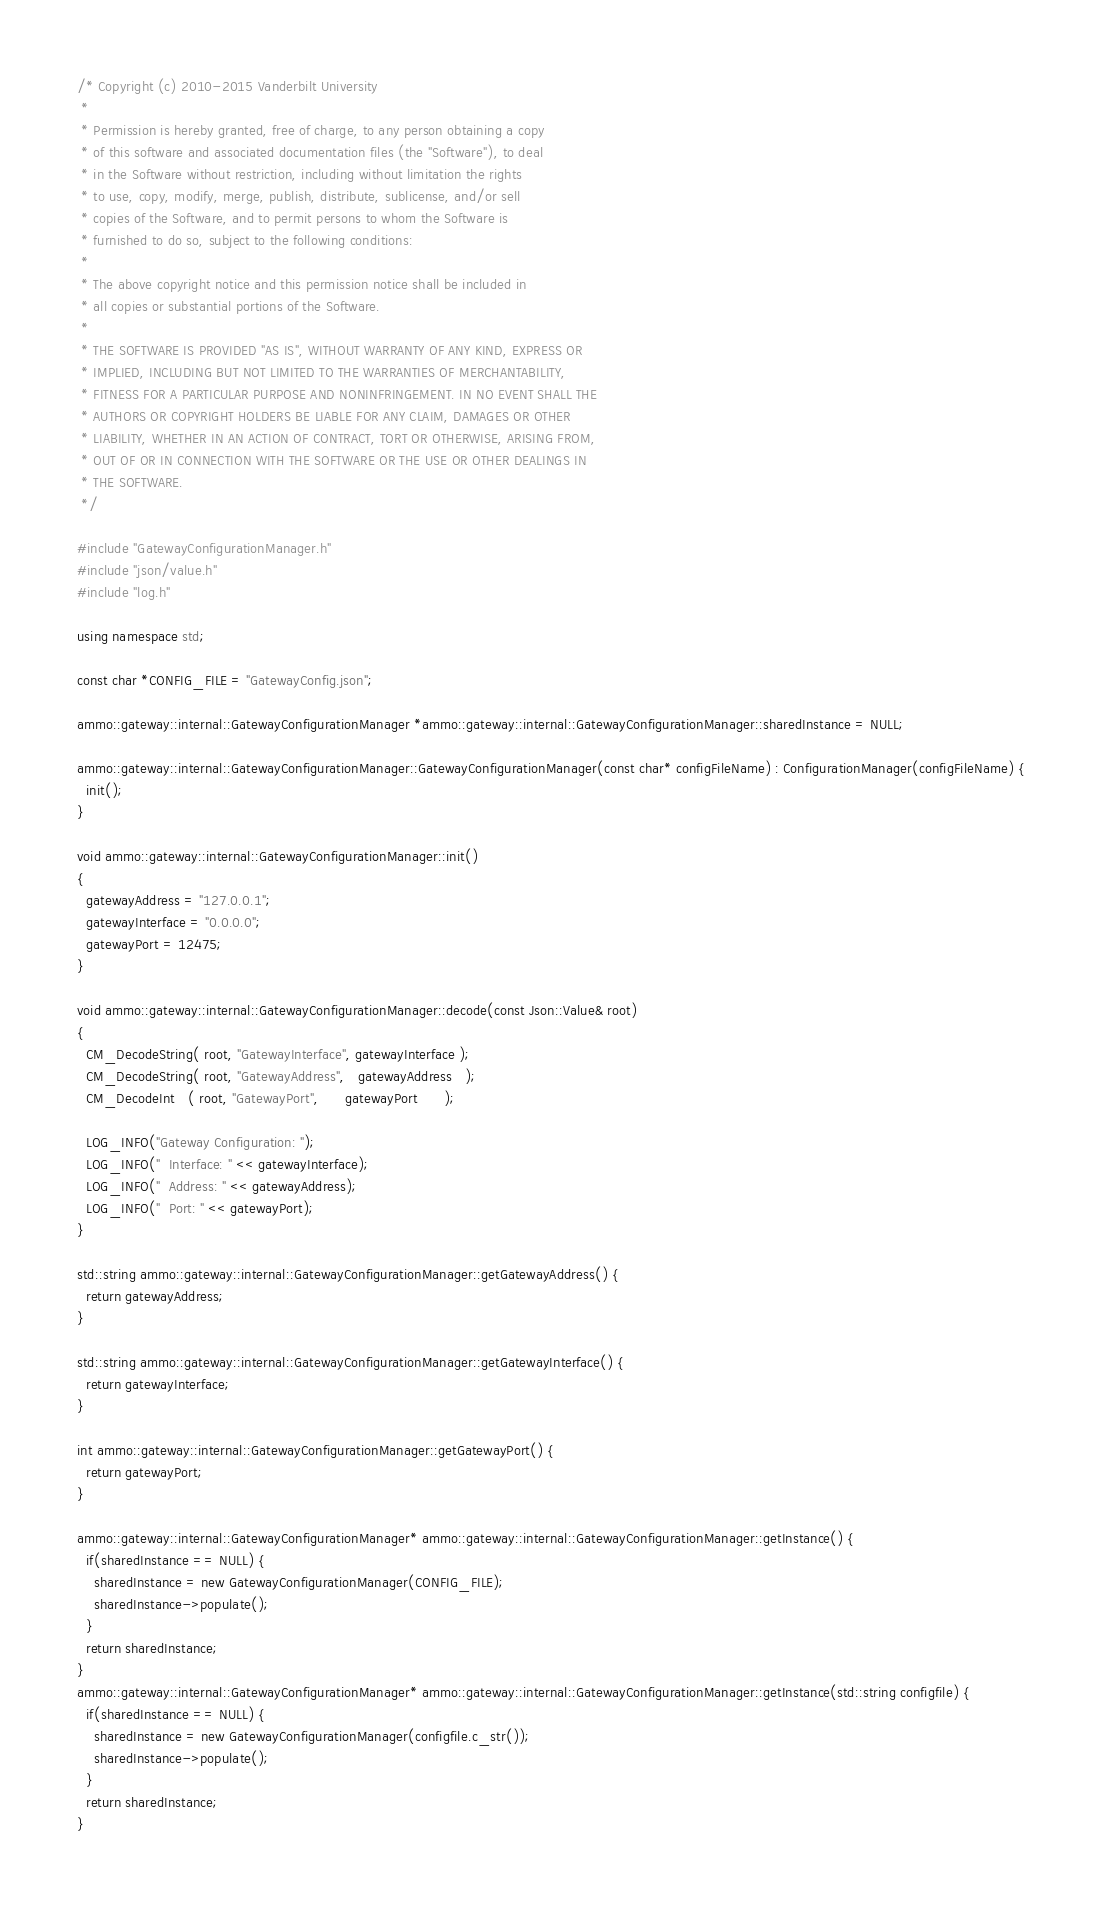Convert code to text. <code><loc_0><loc_0><loc_500><loc_500><_C++_>/* Copyright (c) 2010-2015 Vanderbilt University
 * 
 * Permission is hereby granted, free of charge, to any person obtaining a copy
 * of this software and associated documentation files (the "Software"), to deal
 * in the Software without restriction, including without limitation the rights
 * to use, copy, modify, merge, publish, distribute, sublicense, and/or sell
 * copies of the Software, and to permit persons to whom the Software is
 * furnished to do so, subject to the following conditions:
 * 
 * The above copyright notice and this permission notice shall be included in
 * all copies or substantial portions of the Software.
 * 
 * THE SOFTWARE IS PROVIDED "AS IS", WITHOUT WARRANTY OF ANY KIND, EXPRESS OR
 * IMPLIED, INCLUDING BUT NOT LIMITED TO THE WARRANTIES OF MERCHANTABILITY,
 * FITNESS FOR A PARTICULAR PURPOSE AND NONINFRINGEMENT. IN NO EVENT SHALL THE
 * AUTHORS OR COPYRIGHT HOLDERS BE LIABLE FOR ANY CLAIM, DAMAGES OR OTHER
 * LIABILITY, WHETHER IN AN ACTION OF CONTRACT, TORT OR OTHERWISE, ARISING FROM,
 * OUT OF OR IN CONNECTION WITH THE SOFTWARE OR THE USE OR OTHER DEALINGS IN
 * THE SOFTWARE.
 */

#include "GatewayConfigurationManager.h"
#include "json/value.h"
#include "log.h"

using namespace std;

const char *CONFIG_FILE = "GatewayConfig.json";

ammo::gateway::internal::GatewayConfigurationManager *ammo::gateway::internal::GatewayConfigurationManager::sharedInstance = NULL;

ammo::gateway::internal::GatewayConfigurationManager::GatewayConfigurationManager(const char* configFileName) : ConfigurationManager(configFileName) {
  init();
}

void ammo::gateway::internal::GatewayConfigurationManager::init()
{
  gatewayAddress = "127.0.0.1";
  gatewayInterface = "0.0.0.0";
  gatewayPort = 12475;
}

void ammo::gateway::internal::GatewayConfigurationManager::decode(const Json::Value& root)
{
  CM_DecodeString( root, "GatewayInterface", gatewayInterface );
  CM_DecodeString( root, "GatewayAddress",   gatewayAddress   );
  CM_DecodeInt   ( root, "GatewayPort",      gatewayPort      );

  LOG_INFO("Gateway Configuration: ");
  LOG_INFO("  Interface: " << gatewayInterface);
  LOG_INFO("  Address: " << gatewayAddress);
  LOG_INFO("  Port: " << gatewayPort);
}

std::string ammo::gateway::internal::GatewayConfigurationManager::getGatewayAddress() {
  return gatewayAddress;
}

std::string ammo::gateway::internal::GatewayConfigurationManager::getGatewayInterface() {
  return gatewayInterface;
}

int ammo::gateway::internal::GatewayConfigurationManager::getGatewayPort() {
  return gatewayPort;
}

ammo::gateway::internal::GatewayConfigurationManager* ammo::gateway::internal::GatewayConfigurationManager::getInstance() {
  if(sharedInstance == NULL) {
    sharedInstance = new GatewayConfigurationManager(CONFIG_FILE);
	sharedInstance->populate();
  }
  return sharedInstance;
}
ammo::gateway::internal::GatewayConfigurationManager* ammo::gateway::internal::GatewayConfigurationManager::getInstance(std::string configfile) {
  if(sharedInstance == NULL) {
    sharedInstance = new GatewayConfigurationManager(configfile.c_str());
	sharedInstance->populate();
  }
  return sharedInstance;
}
</code> 